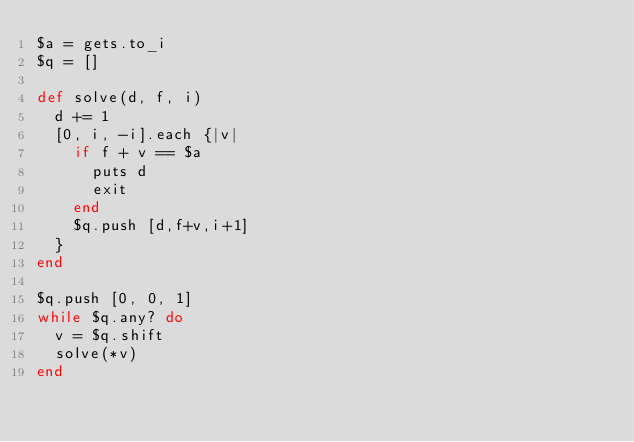Convert code to text. <code><loc_0><loc_0><loc_500><loc_500><_Ruby_>$a = gets.to_i
$q = []

def solve(d, f, i)
  d += 1
  [0, i, -i].each {|v|
    if f + v == $a
      puts d
      exit
    end
    $q.push [d,f+v,i+1]
  }
end

$q.push [0, 0, 1]
while $q.any? do
  v = $q.shift
  solve(*v)
end
</code> 